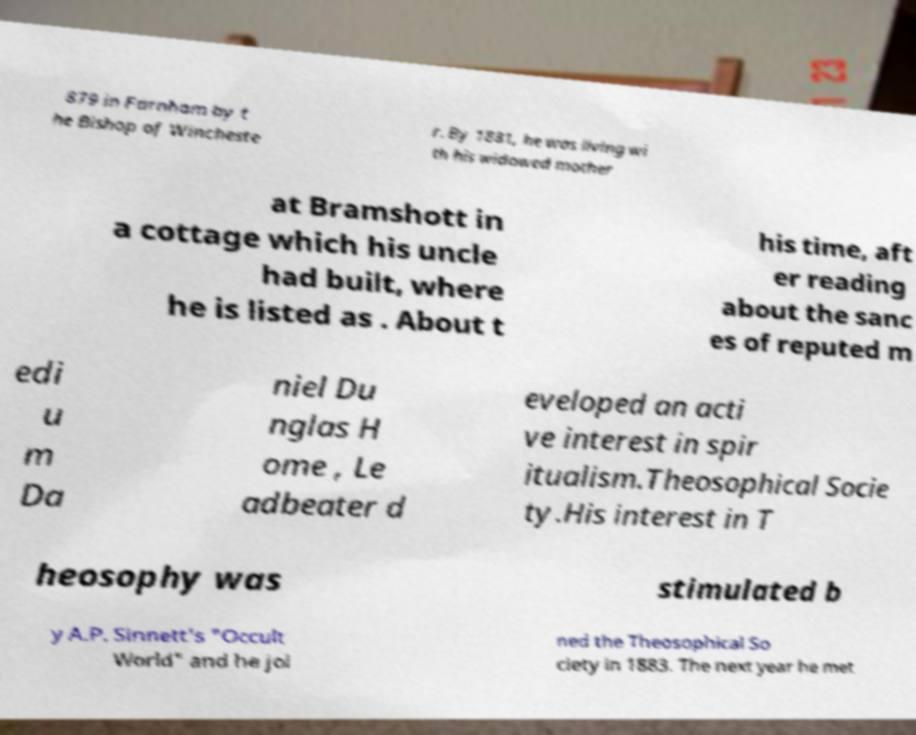Please identify and transcribe the text found in this image. 879 in Farnham by t he Bishop of Wincheste r. By 1881, he was living wi th his widowed mother at Bramshott in a cottage which his uncle had built, where he is listed as . About t his time, aft er reading about the sanc es of reputed m edi u m Da niel Du nglas H ome , Le adbeater d eveloped an acti ve interest in spir itualism.Theosophical Socie ty.His interest in T heosophy was stimulated b y A.P. Sinnett's "Occult World" and he joi ned the Theosophical So ciety in 1883. The next year he met 